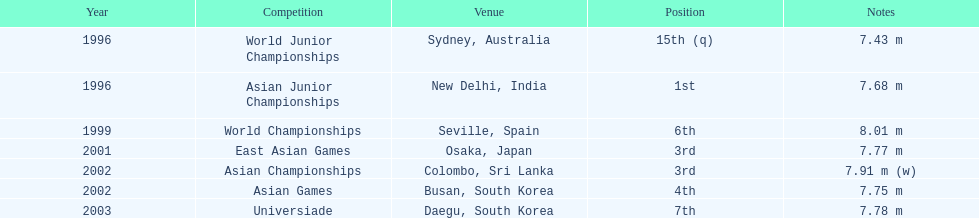Could you parse the entire table as a dict? {'header': ['Year', 'Competition', 'Venue', 'Position', 'Notes'], 'rows': [['1996', 'World Junior Championships', 'Sydney, Australia', '15th (q)', '7.43 m'], ['1996', 'Asian Junior Championships', 'New Delhi, India', '1st', '7.68 m'], ['1999', 'World Championships', 'Seville, Spain', '6th', '8.01 m'], ['2001', 'East Asian Games', 'Osaka, Japan', '3rd', '7.77 m'], ['2002', 'Asian Championships', 'Colombo, Sri Lanka', '3rd', '7.91 m (w)'], ['2002', 'Asian Games', 'Busan, South Korea', '4th', '7.75 m'], ['2003', 'Universiade', 'Daegu, South Korea', '7th', '7.78 m']]} How many times did his jump surpass 7.70 m? 5. 